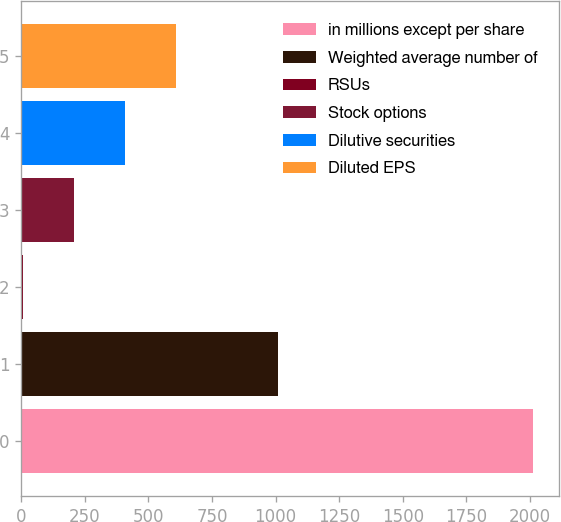Convert chart to OTSL. <chart><loc_0><loc_0><loc_500><loc_500><bar_chart><fcel>in millions except per share<fcel>Weighted average number of<fcel>RSUs<fcel>Stock options<fcel>Dilutive securities<fcel>Diluted EPS<nl><fcel>2014<fcel>1010.05<fcel>6.1<fcel>206.89<fcel>407.68<fcel>608.47<nl></chart> 